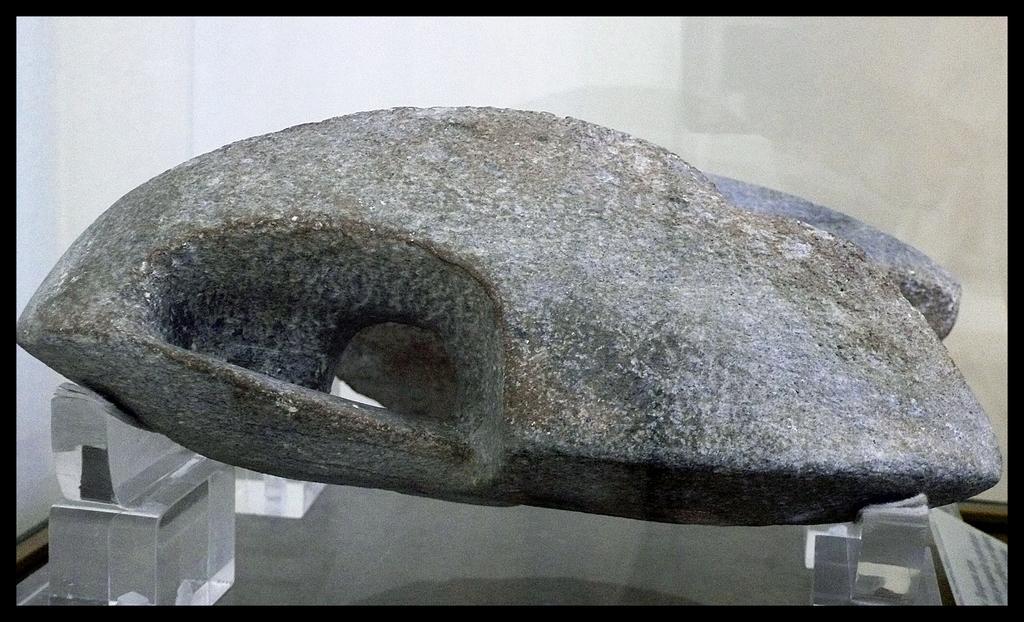How would you summarize this image in a sentence or two? In this picture we can see a stone on some glass objects. Behind the stone there is a wall. 